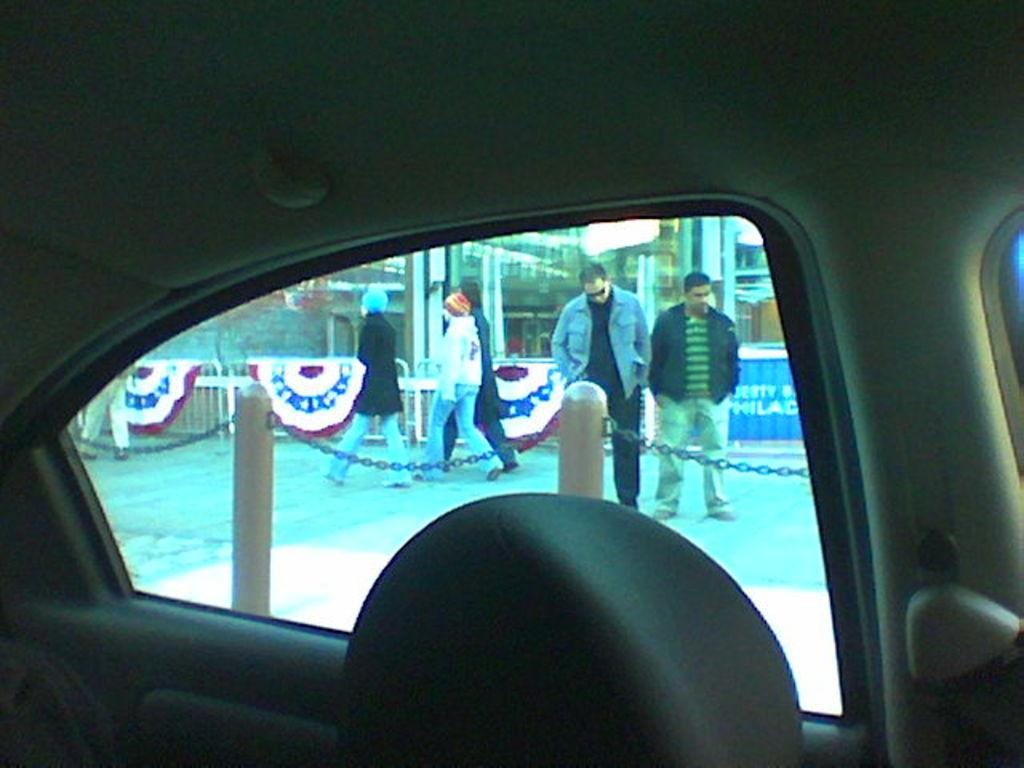What is the main subject of the image? The main subject of the image is a vehicle. What can be seen through the glass doors of the vehicle? There are people walking on the road visible through the glass doors of the vehicle. What is present in the background of the image? There is a fence in the image. What part of the vehicle is visible in the image? The glass doors of the vehicle are visible. How many oranges are being weighed on the scale in the image? There are no oranges or scales present in the image. What type of meeting is taking place inside the vehicle in the image? There is no meeting taking place inside the vehicle in the image. 